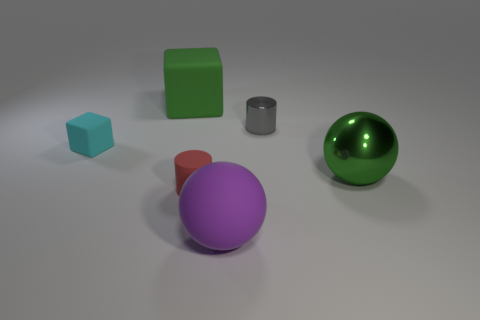How many other objects are the same size as the red matte thing? Upon examining the objects, it seems there are two objects that are approximately the same size as the red cylinder. These are the small blue cube and the small grey cylinder. 